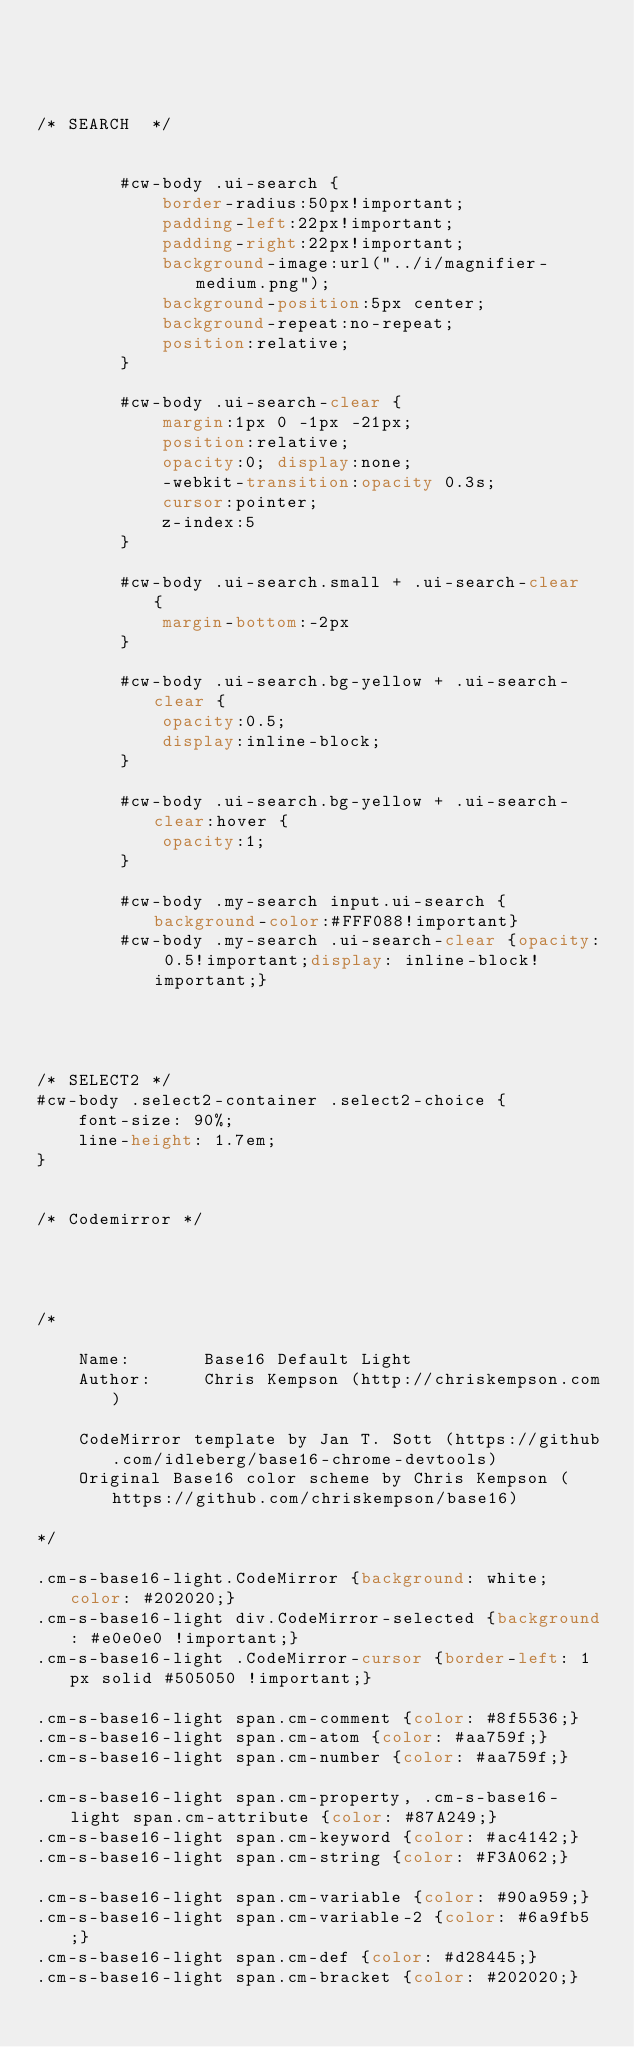<code> <loc_0><loc_0><loc_500><loc_500><_CSS_>



/* SEARCH  */


		#cw-body .ui-search {
			border-radius:50px!important;
			padding-left:22px!important;
			padding-right:22px!important;
			background-image:url("../i/magnifier-medium.png"); 
			background-position:5px center; 
			background-repeat:no-repeat;
			position:relative;
		}
		
		#cw-body .ui-search-clear {
			margin:1px 0 -1px -21px;
			position:relative;
			opacity:0; display:none;
			-webkit-transition:opacity 0.3s;
			cursor:pointer;
			z-index:5
		}
		
		#cw-body .ui-search.small + .ui-search-clear  {
			margin-bottom:-2px
		}
		
		#cw-body .ui-search.bg-yellow + .ui-search-clear {
			opacity:0.5;
			display:inline-block;
		}
		
		#cw-body .ui-search.bg-yellow + .ui-search-clear:hover {
			opacity:1;
		}
		
		#cw-body .my-search input.ui-search {background-color:#FFF088!important}
		#cw-body .my-search .ui-search-clear {opacity: 0.5!important;display: inline-block!important;}

	
	
	
/* SELECT2 */
#cw-body .select2-container .select2-choice {
	font-size: 90%;
	line-height: 1.7em;
}


/* Codemirror */




/*

    Name:       Base16 Default Light
    Author:     Chris Kempson (http://chriskempson.com)

    CodeMirror template by Jan T. Sott (https://github.com/idleberg/base16-chrome-devtools)
    Original Base16 color scheme by Chris Kempson (https://github.com/chriskempson/base16)

*/

.cm-s-base16-light.CodeMirror {background: white; color: #202020;}
.cm-s-base16-light div.CodeMirror-selected {background: #e0e0e0 !important;}
.cm-s-base16-light .CodeMirror-cursor {border-left: 1px solid #505050 !important;}

.cm-s-base16-light span.cm-comment {color: #8f5536;}
.cm-s-base16-light span.cm-atom {color: #aa759f;}
.cm-s-base16-light span.cm-number {color: #aa759f;}

.cm-s-base16-light span.cm-property, .cm-s-base16-light span.cm-attribute {color: #87A249;}
.cm-s-base16-light span.cm-keyword {color: #ac4142;}
.cm-s-base16-light span.cm-string {color: #F3A062;}

.cm-s-base16-light span.cm-variable {color: #90a959;}
.cm-s-base16-light span.cm-variable-2 {color: #6a9fb5;}
.cm-s-base16-light span.cm-def {color: #d28445;}
.cm-s-base16-light span.cm-bracket {color: #202020;}</code> 